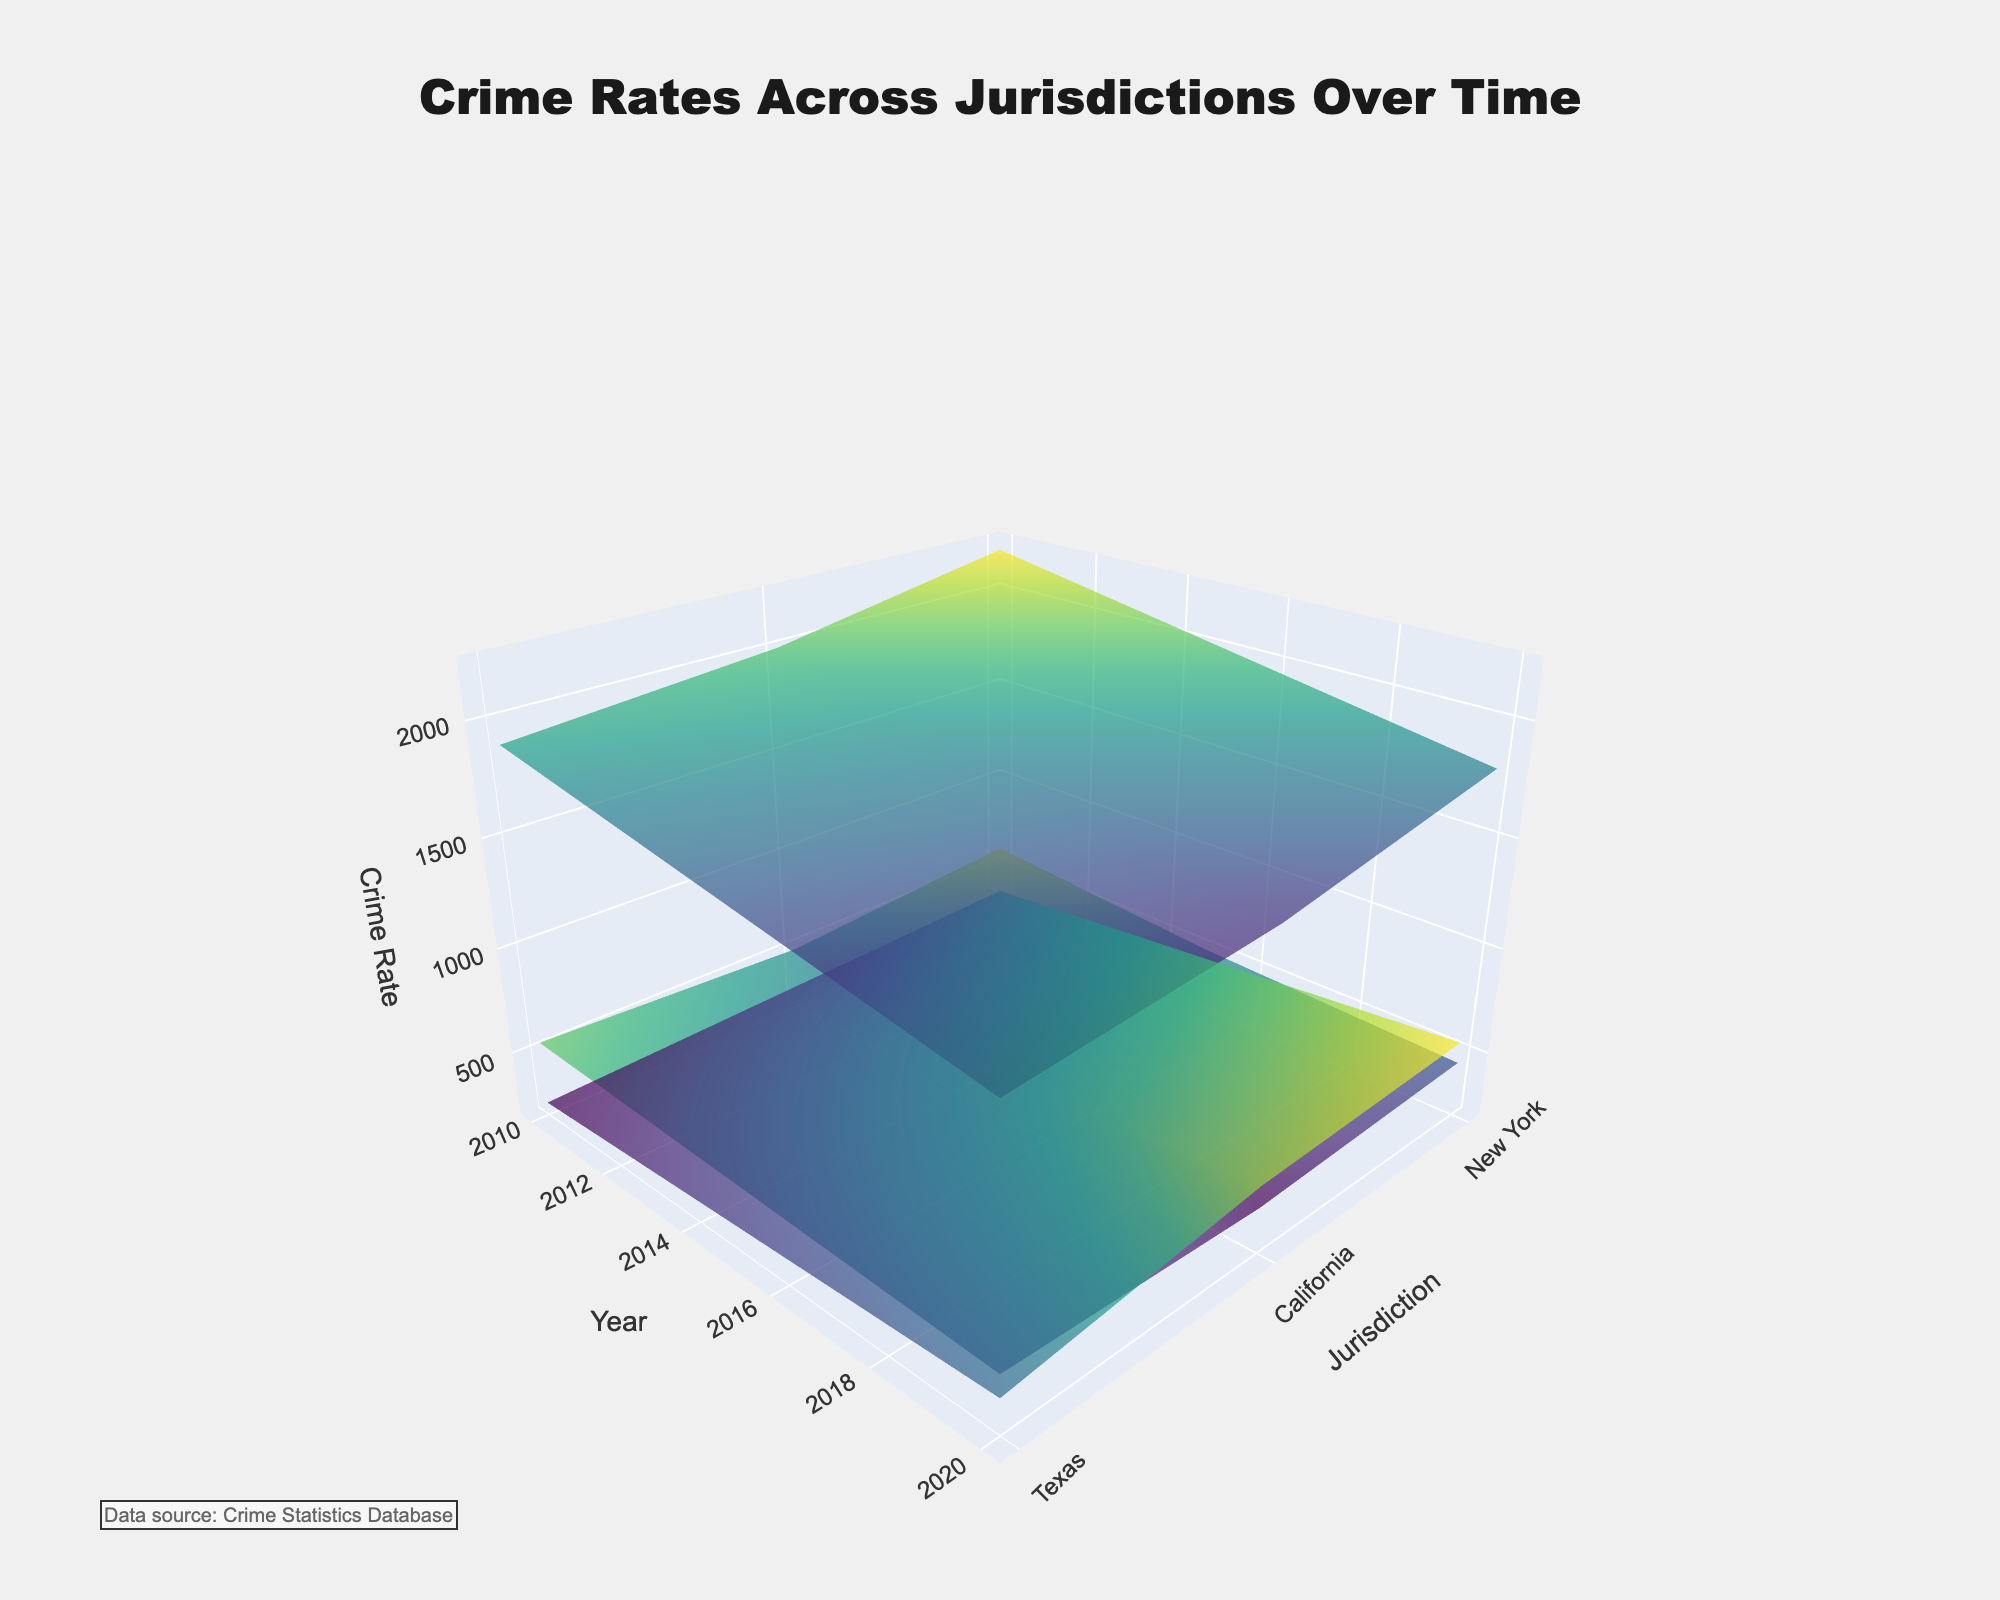What is the title of the 3D surface plot? The title of a plot is usually found at the top and provides a brief description of what the plot represents. Here, it reads "Crime Rates Across Jurisdictions Over Time."
Answer: Crime Rates Across Jurisdictions Over Time Which jurisdiction had the highest violent crime rate in 2010? To determine this, you look at the highest point on the "Violent Crime" surface for the year 2010. In this plot, California had the highest violent crime rate in 2010.
Answer: California What did the property crime rate trend look like for New York over time? Observing the "Property Crime" surface for New York along the year axis, we see a consistent decline in property crime rates from 2010 to 2020.
Answer: Declining How did white-collar crime rates in Texas change from 2010 to 2020? By following the "White Collar Crime" surface for Texas from 2010 to 2020, we notice an increasing trend.
Answer: Increasing Which crime category showed the most significant decrease in California from 2010 to 2020? By comparing all three crime surfaces (Violent Crime, Property Crime, White Collar Crime) for California from 2010 to 2020, it is clear that Violent Crime rates showed the most significant decrease.
Answer: Violent Crime In 2015, which jurisdiction had the lowest property crime rate? On the "Property Crime" surface plot for the year 2015, the lowest point corresponds to Texas.
Answer: Texas What is the primary color scale used in this 3D surface plot? The color scale used to represent the different scales of crime rates is called "Viridis," which ranges in shades of green, yellow, and purple.
Answer: Viridis Did any jurisdiction experience an increase in violent and white-collar crime rates simultaneously between 2010 to 2020? By closely examining the surfaces, we identify that New York experienced increases in both violent and white-collar crime rates between 2010 to 2020.
Answer: New York Which jurisdiction and year had the lowest white-collar crime rate? Check the lowest point on the "White Collar Crime" surface across all jurisdictions and years. The lowest point appears to be Texas in 2010.
Answer: Texas, 2010 Comparing New York and California, which jurisdiction had higher property crime rates consistently over the years? By analyzing the "Property Crime" surfaces for both New York and California across all years, it is evident that California had higher property crime rates consistently.
Answer: California 